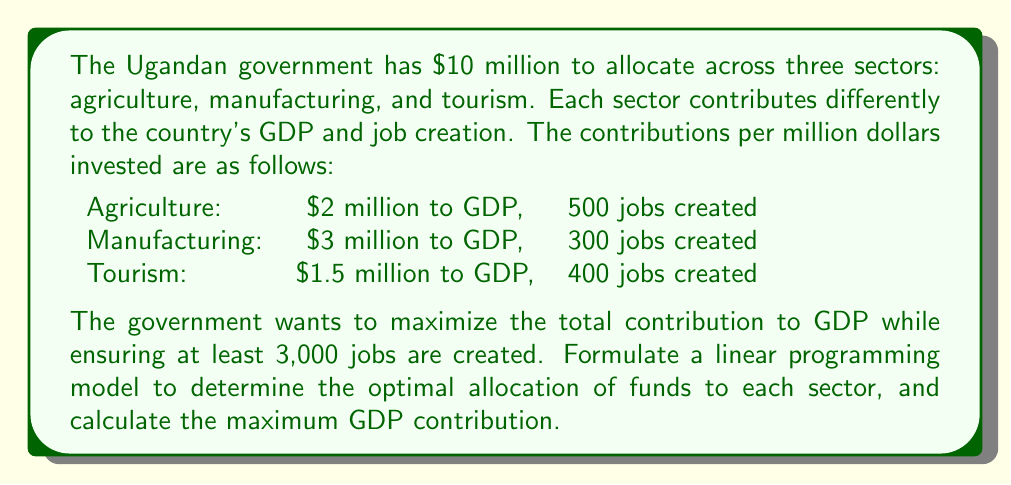Can you solve this math problem? Let's solve this step-by-step using linear programming:

1. Define variables:
   Let $x_1$, $x_2$, and $x_3$ be the amount (in millions) allocated to agriculture, manufacturing, and tourism respectively.

2. Objective function:
   Maximize GDP contribution: $Z = 2x_1 + 3x_2 + 1.5x_3$

3. Constraints:
   a) Total budget: $x_1 + x_2 + x_3 \leq 10$
   b) Job creation: $500x_1 + 300x_2 + 400x_3 \geq 3000$
   c) Non-negativity: $x_1, x_2, x_3 \geq 0$

4. Solve using the simplex method or a linear programming solver:

   The optimal solution is:
   $x_1 = 6$, $x_2 = 4$, $x_3 = 0$

5. Calculate the maximum GDP contribution:
   $Z = 2(6) + 3(4) + 1.5(0) = 12 + 12 + 0 = 24$

Therefore, the optimal allocation is to invest $6 million in agriculture and $4 million in manufacturing, with no investment in tourism. This allocation will maximize the GDP contribution at $24 million.
Answer: $24 million GDP contribution with $6 million to agriculture, $4 million to manufacturing 